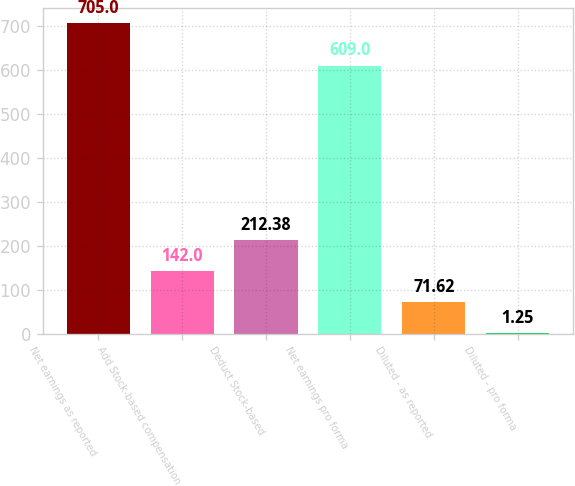Convert chart. <chart><loc_0><loc_0><loc_500><loc_500><bar_chart><fcel>Net earnings as reported<fcel>Add Stock-based compensation<fcel>Deduct Stock-based<fcel>Net earnings pro forma<fcel>Diluted - as reported<fcel>Diluted - pro forma<nl><fcel>705<fcel>142<fcel>212.38<fcel>609<fcel>71.62<fcel>1.25<nl></chart> 